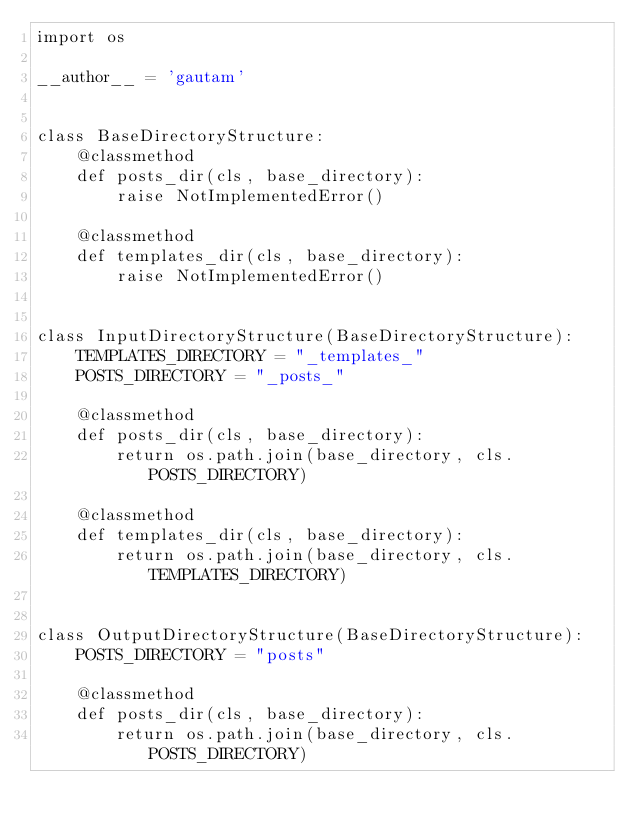Convert code to text. <code><loc_0><loc_0><loc_500><loc_500><_Python_>import os

__author__ = 'gautam'


class BaseDirectoryStructure:
    @classmethod
    def posts_dir(cls, base_directory):
        raise NotImplementedError()

    @classmethod
    def templates_dir(cls, base_directory):
        raise NotImplementedError()


class InputDirectoryStructure(BaseDirectoryStructure):
    TEMPLATES_DIRECTORY = "_templates_"
    POSTS_DIRECTORY = "_posts_"

    @classmethod
    def posts_dir(cls, base_directory):
        return os.path.join(base_directory, cls.POSTS_DIRECTORY)

    @classmethod
    def templates_dir(cls, base_directory):
        return os.path.join(base_directory, cls.TEMPLATES_DIRECTORY)


class OutputDirectoryStructure(BaseDirectoryStructure):
    POSTS_DIRECTORY = "posts"

    @classmethod
    def posts_dir(cls, base_directory):
        return os.path.join(base_directory, cls.POSTS_DIRECTORY)</code> 